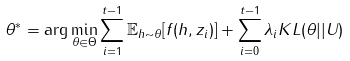Convert formula to latex. <formula><loc_0><loc_0><loc_500><loc_500>\theta ^ { * } = \arg \min _ { \theta \in \Theta } \sum _ { i = 1 } ^ { t - 1 } \mathbb { E } _ { h \sim \theta } [ f ( h , z _ { i } ) ] + \sum _ { i = 0 } ^ { t - 1 } \lambda _ { i } K L ( \theta | | U )</formula> 